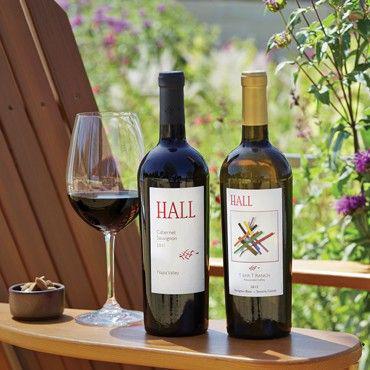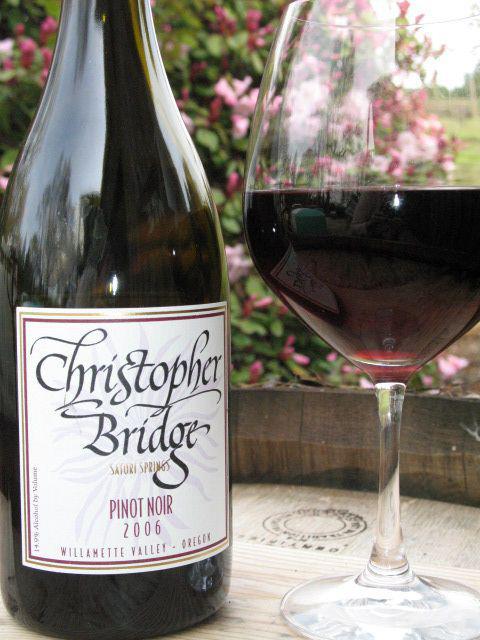The first image is the image on the left, the second image is the image on the right. Considering the images on both sides, is "A green wine bottle is to the right of a glass of wine in the right image." valid? Answer yes or no. No. The first image is the image on the left, the second image is the image on the right. Analyze the images presented: Is the assertion "All pictures include at least one wine glass." valid? Answer yes or no. Yes. 